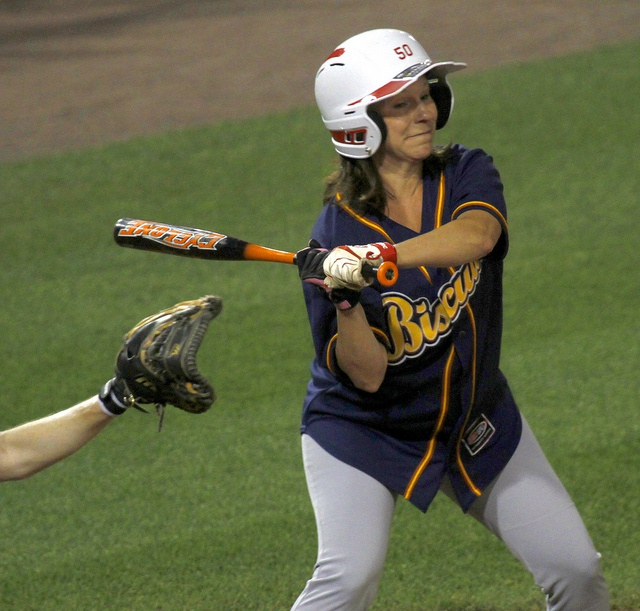Describe the objects in this image and their specific colors. I can see people in black, darkgray, white, and olive tones, baseball glove in black, gray, darkgreen, and olive tones, and baseball bat in black, red, lightgray, and gray tones in this image. 